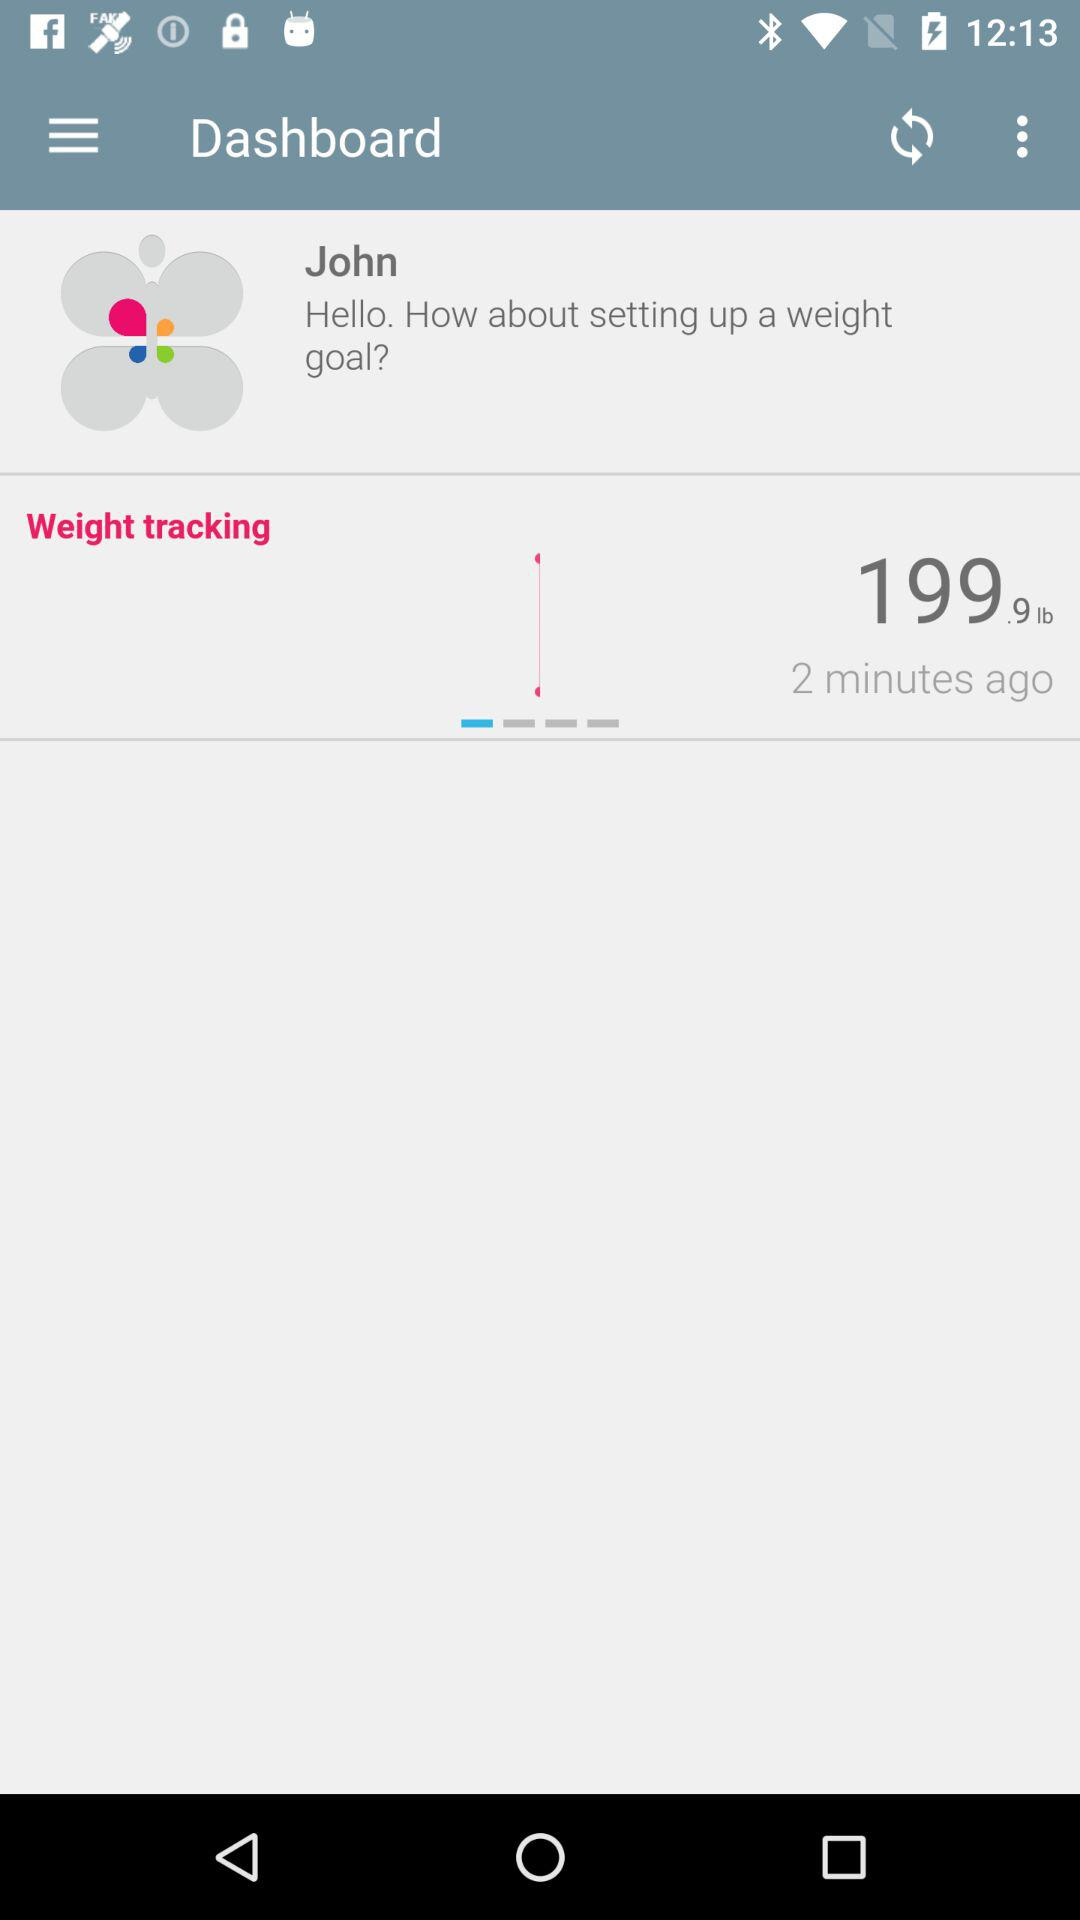What is the weight? The weight is 199.9 lb. 